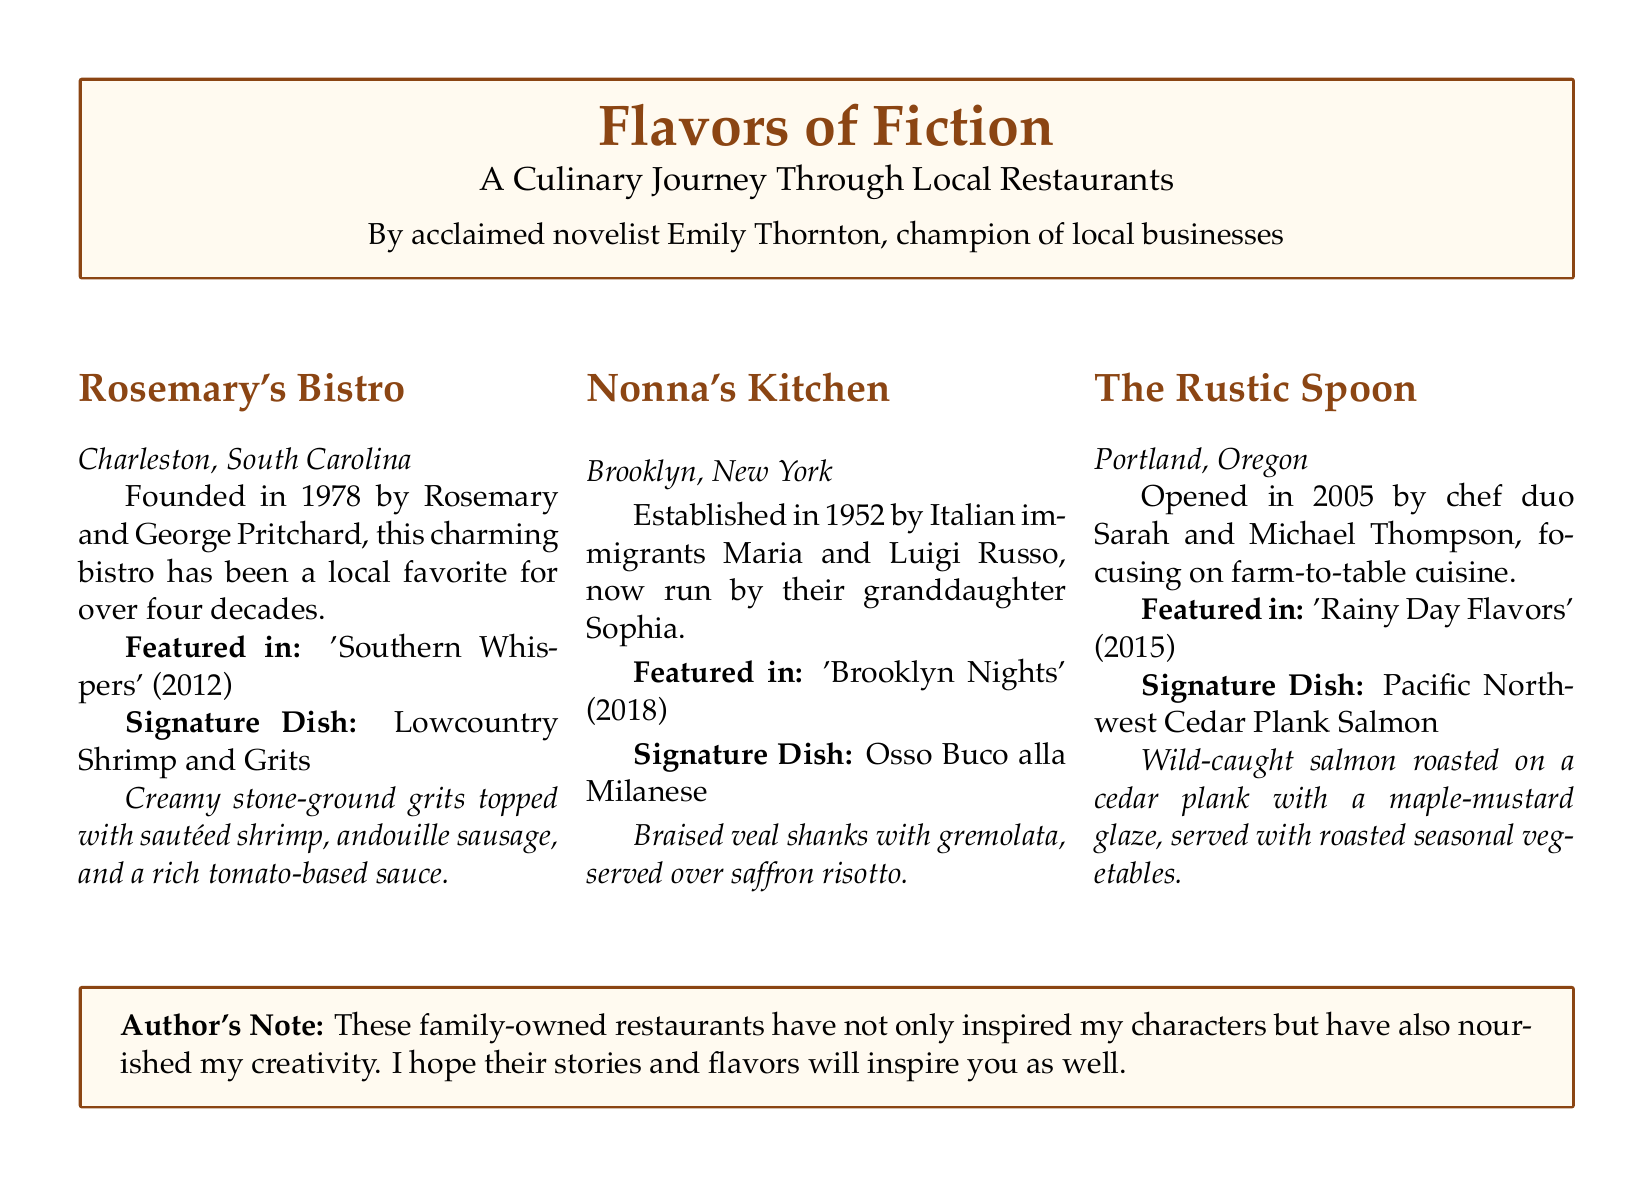What is the name of the bistro in Charleston? The document states that the bistro in Charleston is called Rosemary's Bistro.
Answer: Rosemary's Bistro When was Nonna's Kitchen established? According to the document, Nonna's Kitchen was established in 1952.
Answer: 1952 What is the signature dish of The Rustic Spoon? The document mentions that The Rustic Spoon's signature dish is Pacific Northwest Cedar Plank Salmon.
Answer: Pacific Northwest Cedar Plank Salmon Who founded Rosemary's Bistro? The document states that Rosemary's Bistro was founded by Rosemary and George Pritchard.
Answer: Rosemary and George Pritchard In which novel is the Lowcountry Shrimp and Grits featured? The document indicates that Lowcountry Shrimp and Grits is featured in 'Southern Whispers'.
Answer: 'Southern Whispers' What type of cuisine does The Rustic Spoon focus on? The document states that The Rustic Spoon focuses on farm-to-table cuisine.
Answer: Farm-to-table cuisine Who runs Nonna's Kitchen now? The document mentions that Nonna's Kitchen is now run by their granddaughter, Sophia.
Answer: Sophia What year was 'Brooklyn Nights' published? The document indicates that 'Brooklyn Nights' was published in 2018.
Answer: 2018 What is the author's name? The document lists the author's name as Emily Thornton.
Answer: Emily Thornton 